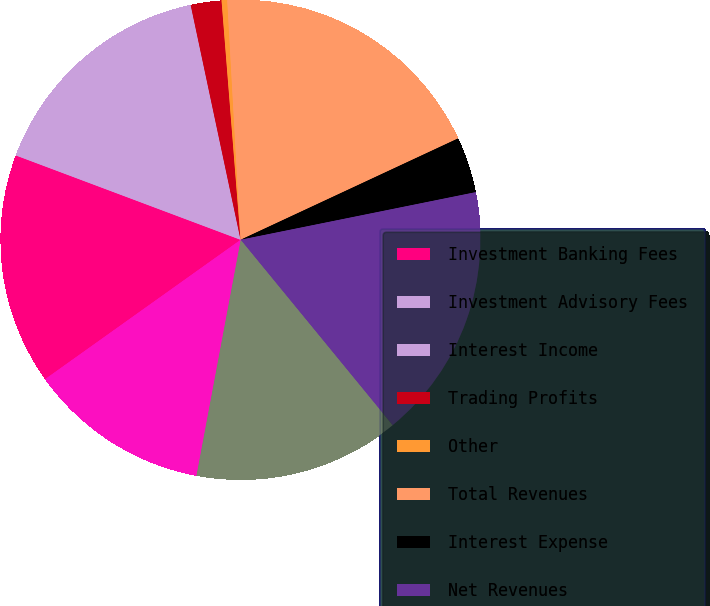Convert chart to OTSL. <chart><loc_0><loc_0><loc_500><loc_500><pie_chart><fcel>Investment Banking Fees<fcel>Investment Advisory Fees<fcel>Interest Income<fcel>Trading Profits<fcel>Other<fcel>Total Revenues<fcel>Interest Expense<fcel>Net Revenues<fcel>Compensation Expense<fcel>Other Expense<nl><fcel>15.57%<fcel>5.44%<fcel>10.51%<fcel>2.07%<fcel>0.38%<fcel>18.94%<fcel>3.76%<fcel>17.25%<fcel>13.88%<fcel>12.19%<nl></chart> 